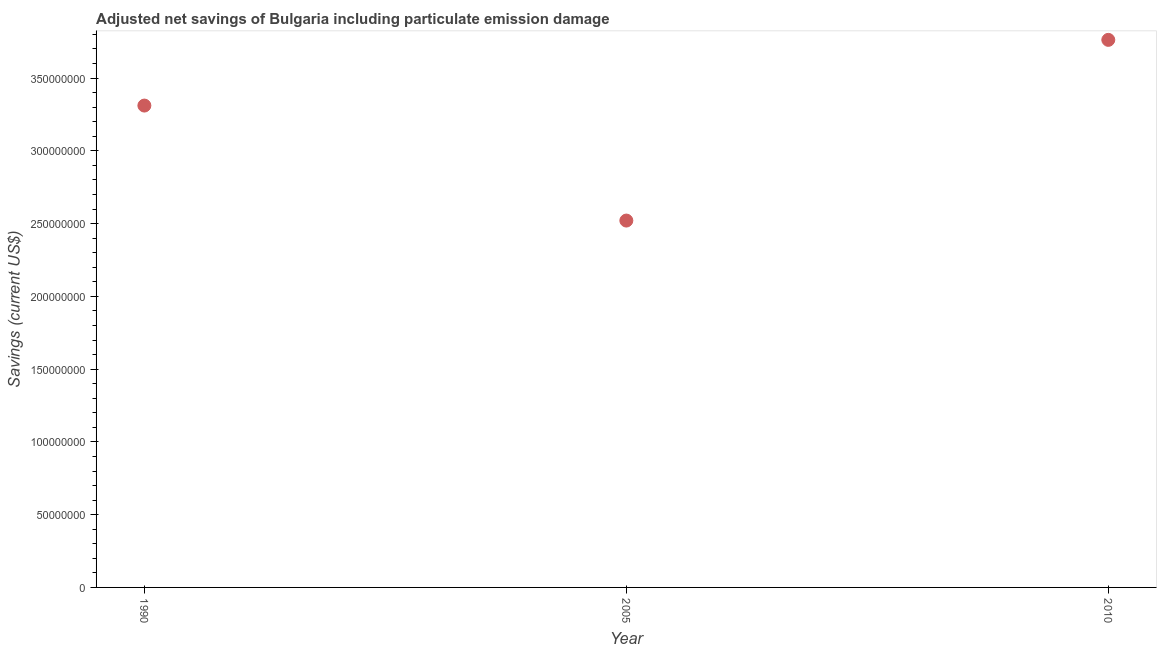What is the adjusted net savings in 1990?
Ensure brevity in your answer.  3.31e+08. Across all years, what is the maximum adjusted net savings?
Your answer should be compact. 3.76e+08. Across all years, what is the minimum adjusted net savings?
Your answer should be compact. 2.52e+08. In which year was the adjusted net savings maximum?
Offer a terse response. 2010. In which year was the adjusted net savings minimum?
Your response must be concise. 2005. What is the sum of the adjusted net savings?
Provide a short and direct response. 9.59e+08. What is the difference between the adjusted net savings in 2005 and 2010?
Your answer should be compact. -1.24e+08. What is the average adjusted net savings per year?
Provide a short and direct response. 3.20e+08. What is the median adjusted net savings?
Offer a very short reply. 3.31e+08. What is the ratio of the adjusted net savings in 1990 to that in 2005?
Provide a succinct answer. 1.31. What is the difference between the highest and the second highest adjusted net savings?
Provide a succinct answer. 4.52e+07. Is the sum of the adjusted net savings in 2005 and 2010 greater than the maximum adjusted net savings across all years?
Give a very brief answer. Yes. What is the difference between the highest and the lowest adjusted net savings?
Keep it short and to the point. 1.24e+08. In how many years, is the adjusted net savings greater than the average adjusted net savings taken over all years?
Keep it short and to the point. 2. How many dotlines are there?
Your answer should be compact. 1. How many years are there in the graph?
Your answer should be compact. 3. What is the difference between two consecutive major ticks on the Y-axis?
Give a very brief answer. 5.00e+07. Does the graph contain any zero values?
Ensure brevity in your answer.  No. Does the graph contain grids?
Give a very brief answer. No. What is the title of the graph?
Your response must be concise. Adjusted net savings of Bulgaria including particulate emission damage. What is the label or title of the X-axis?
Offer a very short reply. Year. What is the label or title of the Y-axis?
Keep it short and to the point. Savings (current US$). What is the Savings (current US$) in 1990?
Your response must be concise. 3.31e+08. What is the Savings (current US$) in 2005?
Offer a terse response. 2.52e+08. What is the Savings (current US$) in 2010?
Provide a short and direct response. 3.76e+08. What is the difference between the Savings (current US$) in 1990 and 2005?
Provide a short and direct response. 7.90e+07. What is the difference between the Savings (current US$) in 1990 and 2010?
Give a very brief answer. -4.52e+07. What is the difference between the Savings (current US$) in 2005 and 2010?
Provide a succinct answer. -1.24e+08. What is the ratio of the Savings (current US$) in 1990 to that in 2005?
Give a very brief answer. 1.31. What is the ratio of the Savings (current US$) in 1990 to that in 2010?
Provide a short and direct response. 0.88. What is the ratio of the Savings (current US$) in 2005 to that in 2010?
Provide a short and direct response. 0.67. 